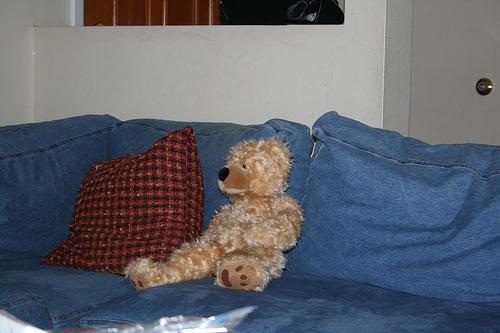Is the toy bear on the sofa life size?
Short answer required. No. Is there a door behind the couch?
Be succinct. Yes. What color is the bear's hair?
Write a very short answer. Tan. 